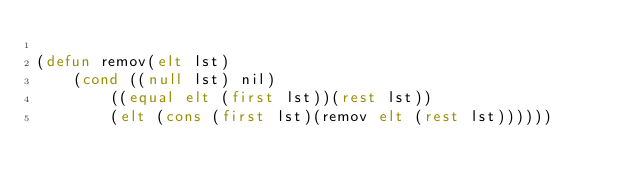Convert code to text. <code><loc_0><loc_0><loc_500><loc_500><_Lisp_>
(defun remov(elt lst)
	(cond ((null lst) nil)
		((equal elt (first lst))(rest lst))
		(elt (cons (first lst)(remov elt (rest lst))))))</code> 